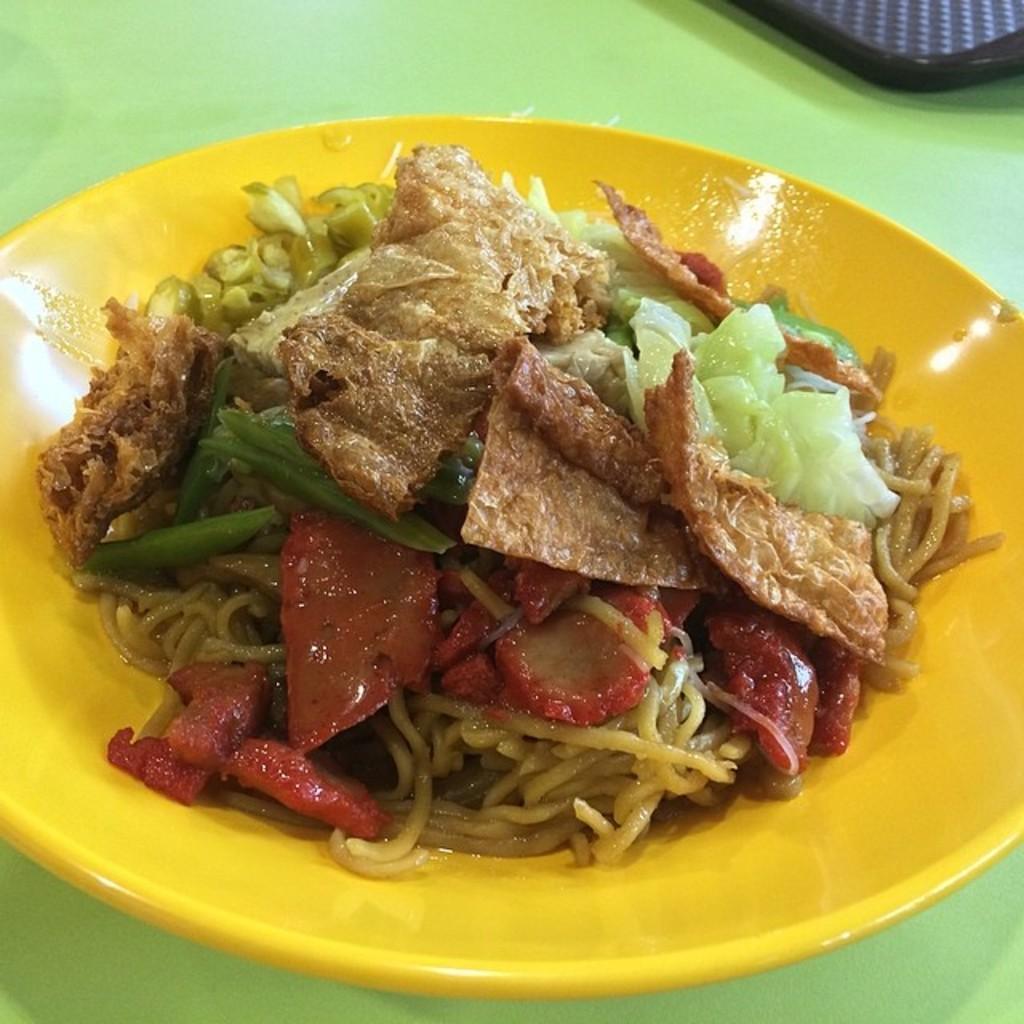Could you give a brief overview of what you see in this image? In this picture we can see an object and a plate with food items on it and these two are placed on a green surface. 